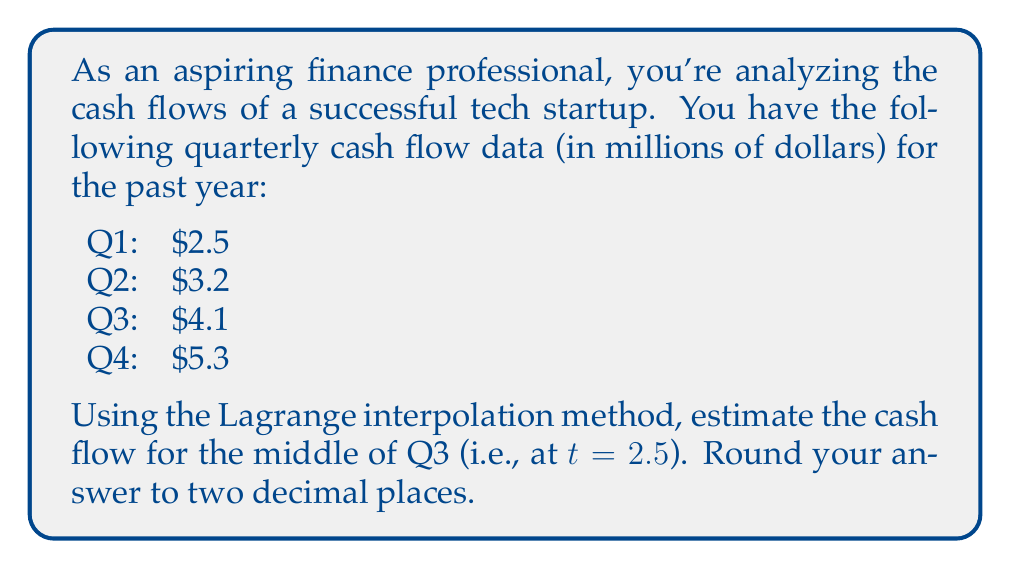What is the answer to this math problem? To solve this problem using Lagrange interpolation, we'll follow these steps:

1) First, let's define our data points:
   $(x_0, y_0) = (0, 2.5)$
   $(x_1, y_1) = (1, 3.2)$
   $(x_2, y_2) = (2, 4.1)$
   $(x_3, y_3) = (3, 5.3)$

2) The Lagrange interpolation formula is:

   $$L(x) = \sum_{i=0}^n y_i \prod_{j\neq i} \frac{x - x_j}{x_i - x_j}$$

3) For our case with 4 points, this expands to:

   $$L(x) = y_0\frac{(x-x_1)(x-x_2)(x-x_3)}{(x_0-x_1)(x_0-x_2)(x_0-x_3)} + y_1\frac{(x-x_0)(x-x_2)(x-x_3)}{(x_1-x_0)(x_1-x_2)(x_1-x_3)} + y_2\frac{(x-x_0)(x-x_1)(x-x_3)}{(x_2-x_0)(x_2-x_1)(x_2-x_3)} + y_3\frac{(x-x_0)(x-x_1)(x-x_2)}{(x_3-x_0)(x_3-x_1)(x_3-x_2)}$$

4) Now, let's substitute our values and x = 2.5:

   $$L(2.5) = 2.5\frac{(2.5-1)(2.5-2)(2.5-3)}{(0-1)(0-2)(0-3)} + 3.2\frac{(2.5-0)(2.5-2)(2.5-3)}{(1-0)(1-2)(1-3)} + 4.1\frac{(2.5-0)(2.5-1)(2.5-3)}{(2-0)(2-1)(2-3)} + 5.3\frac{(2.5-0)(2.5-1)(2.5-2)}{(3-0)(3-1)(3-2)}$$

5) Simplifying:

   $$L(2.5) = 2.5\frac{1.5 \cdot 0.5 \cdot (-0.5)}{-1 \cdot (-2) \cdot (-3)} + 3.2\frac{2.5 \cdot 0.5 \cdot (-0.5)}{1 \cdot (-1) \cdot (-2)} + 4.1\frac{2.5 \cdot 1.5 \cdot (-0.5)}{2 \cdot 1 \cdot (-1)} + 5.3\frac{2.5 \cdot 1.5 \cdot 0.5}{3 \cdot 2 \cdot 1}$$

6) Calculating:

   $$L(2.5) = 2.5 \cdot (-0.15625) + 3.2 \cdot (-0.3125) + 4.1 \cdot 0.9375 + 5.3 \cdot 0.3125$$
   $$L(2.5) = -0.390625 - 1 + 3.84375 + 1.65625$$
   $$L(2.5) = 4.109375$$

7) Rounding to two decimal places:

   $$L(2.5) \approx 4.11$$
Answer: $4.11 million 